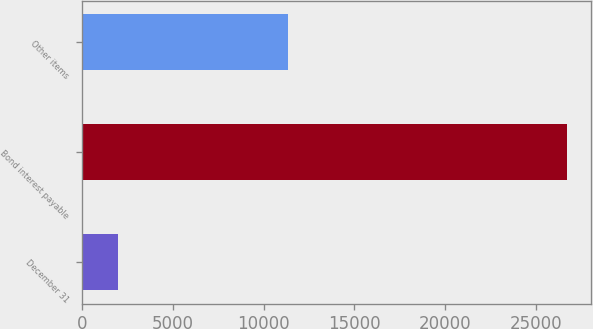<chart> <loc_0><loc_0><loc_500><loc_500><bar_chart><fcel>December 31<fcel>Bond interest payable<fcel>Other items<nl><fcel>2008<fcel>26706<fcel>11321<nl></chart> 